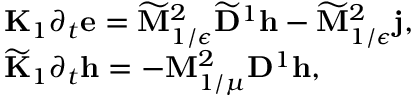<formula> <loc_0><loc_0><loc_500><loc_500>\begin{array} { r l } & { { K } _ { 1 } \partial _ { t } e = \widetilde { M } _ { 1 / \epsilon } ^ { 2 } \widetilde { D } ^ { 1 } h - \widetilde { M } _ { 1 / \epsilon } ^ { 2 } j , } \\ & { \widetilde { K } _ { 1 } \partial _ { t } h = - M _ { 1 / \mu } ^ { 2 } D ^ { 1 } h , } \end{array}</formula> 